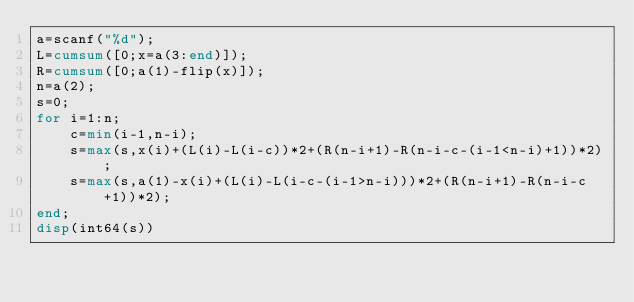Convert code to text. <code><loc_0><loc_0><loc_500><loc_500><_Octave_>a=scanf("%d");
L=cumsum([0;x=a(3:end)]);
R=cumsum([0;a(1)-flip(x)]);
n=a(2);
s=0;
for i=1:n;
	c=min(i-1,n-i);
	s=max(s,x(i)+(L(i)-L(i-c))*2+(R(n-i+1)-R(n-i-c-(i-1<n-i)+1))*2);
	s=max(s,a(1)-x(i)+(L(i)-L(i-c-(i-1>n-i)))*2+(R(n-i+1)-R(n-i-c+1))*2);
end;
disp(int64(s))</code> 